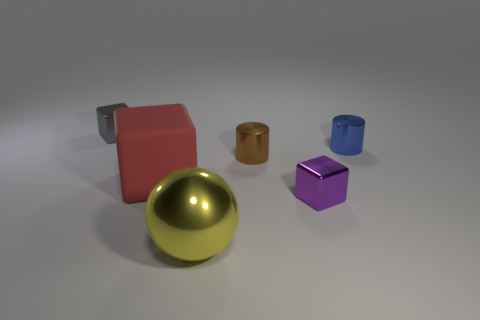Add 1 tiny spheres. How many objects exist? 7 Subtract all balls. How many objects are left? 5 Subtract 0 yellow blocks. How many objects are left? 6 Subtract all big red objects. Subtract all red matte things. How many objects are left? 4 Add 2 brown cylinders. How many brown cylinders are left? 3 Add 6 brown cylinders. How many brown cylinders exist? 7 